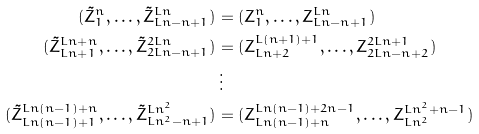Convert formula to latex. <formula><loc_0><loc_0><loc_500><loc_500>( \tilde { Z } _ { 1 } ^ { n } , \dots , \tilde { Z } _ { L n - n + 1 } ^ { L n } ) & = ( Z _ { 1 } ^ { n } , \dots , Z _ { L n - n + 1 } ^ { L n } ) \\ ( \tilde { Z } _ { L n + 1 } ^ { L n + n } , \dots , \tilde { Z } _ { 2 L n - n + 1 } ^ { 2 L n } ) & = ( Z _ { L n + 2 } ^ { L ( n + 1 ) + 1 } , \dots , Z _ { 2 L n - n + 2 } ^ { 2 L n + 1 } ) \\ & \, \vdots \\ ( \tilde { Z } _ { L n ( n - 1 ) + 1 } ^ { L n ( n - 1 ) + n } , \dots , \tilde { Z } _ { L n ^ { 2 } - n + 1 } ^ { L n ^ { 2 } } ) & = ( Z _ { L n ( n - 1 ) + n } ^ { L n ( n - 1 ) + 2 n - 1 } , \dots , Z _ { L n ^ { 2 } } ^ { L n ^ { 2 } + n - 1 } )</formula> 